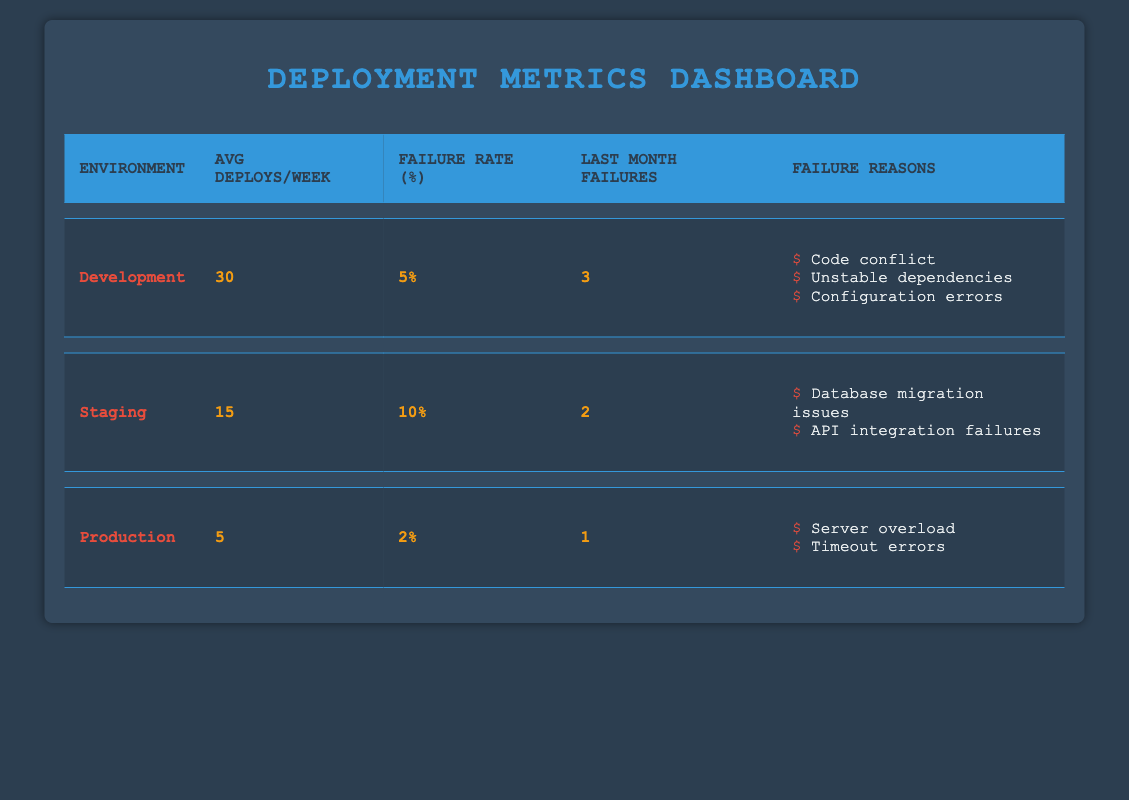What is the average number of deployments per week in the development environment? According to the table, the average number of deployments per week in the development environment is explicitly stated as 30.
Answer: 30 Which environment has the highest failure rate? The failure rates for the environments are 5% for development, 10% for staging, and 2% for production. Staging has the highest failure rate at 10%.
Answer: Staging How many failures occurred last month in the production environment? The table shows that there was 1 failure in the production environment last month.
Answer: 1 What is the difference in failure rates between development and production environments? The failure rate for development is 5% and for production is 2%. The difference is 5% - 2% = 3%.
Answer: 3% Are there any failure reasons listed for the production environment? Yes, the failure reasons for the production environment include server overload and timeout errors. Both are explicitly mentioned in the table.
Answer: Yes What is the average number of deployments per week across all environments? The average can be calculated by summing the average deploys per week for all environments: (30 for development + 15 for staging + 5 for production) / 3 environments = 50/3. This results in approximately 16.67.
Answer: 16.67 Is the failure rate in the staging environment less than the development environment? The failure rate in staging is 10%, which is higher than the development environment's rate of 5%. Therefore, the statement is false.
Answer: No Which environment had the least number of failures last month? The total failures last month were 3 in development, 2 in staging, and 1 in production. Production had the least with only 1 failure.
Answer: Production 